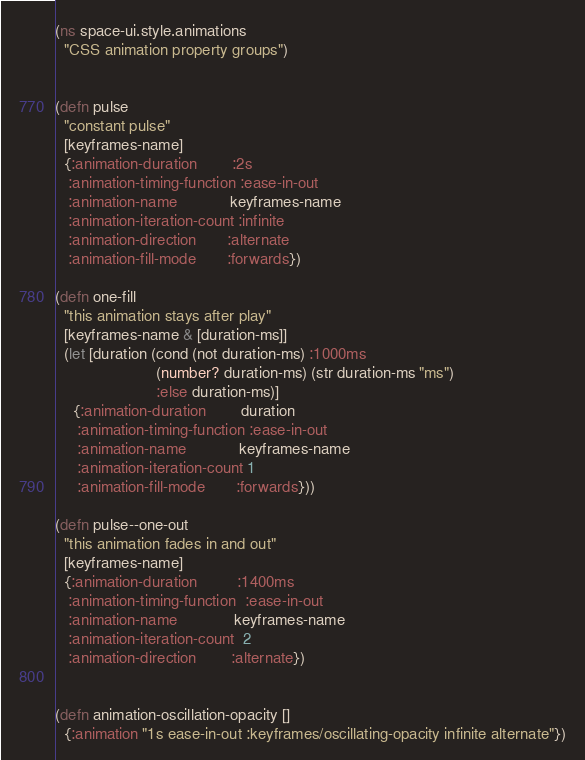<code> <loc_0><loc_0><loc_500><loc_500><_Clojure_>(ns space-ui.style.animations
  "CSS animation property groups")


(defn pulse
  "constant pulse"
  [keyframes-name]
  {:animation-duration        :2s
   :animation-timing-function :ease-in-out
   :animation-name            keyframes-name
   :animation-iteration-count :infinite
   :animation-direction       :alternate
   :animation-fill-mode       :forwards})

(defn one-fill
  "this animation stays after play"
  [keyframes-name & [duration-ms]]
  (let [duration (cond (not duration-ms) :1000ms
                       (number? duration-ms) (str duration-ms "ms")
                       :else duration-ms)]
    {:animation-duration        duration
     :animation-timing-function :ease-in-out
     :animation-name            keyframes-name
     :animation-iteration-count 1
     :animation-fill-mode       :forwards}))

(defn pulse--one-out
  "this animation fades in and out"
  [keyframes-name]
  {:animation-duration         :1400ms
   :animation-timing-function  :ease-in-out
   :animation-name             keyframes-name
   :animation-iteration-count  2
   :animation-direction        :alternate})


(defn animation-oscillation-opacity []
  {:animation "1s ease-in-out :keyframes/oscillating-opacity infinite alternate"})


</code> 